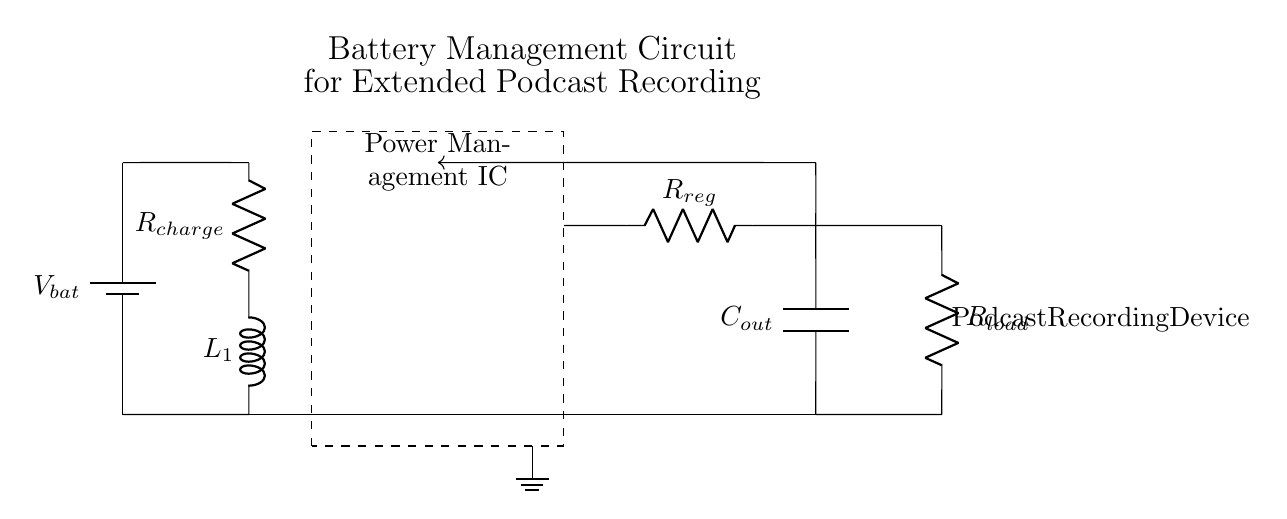What is the component responsible for regulating the output voltage? The component responsible for regulating the output voltage is the voltage regulator, indicated as R sub reg in the circuit.
Answer: R sub reg What does the circuit use to store energy for powering the podcast recording device? The circuit uses an output capacitor, shown as C sub out, to store energy. Energy is stored in capacitors by holding an electric charge.
Answer: C sub out What is the purpose of the Power Management IC block? The Power Management IC block is designed to manage the power supply and distribution within the circuit, ensuring the components receive the correct voltage levels for optimal performance.
Answer: Manage power supply What is the role of the inductor in this circuit? The inductor, labeled as L sub 1, is used in the charging circuit to store energy in a magnetic field and help smooth out fluctuations in the current, enhancing stability during operation.
Answer: Smooth current How does the feedback loop function in this circuit? The feedback loop provides a way to adjust the operation of the power management IC based on the output voltage, allowing for improved regulation of the circuit's performance and maintaining the desired voltage level for the load.
Answer: Adjusts output voltage What is the main load in this battery management circuit? The main load in this battery management circuit is the podcast recording device, which is indicated in the diagram next to the resistor marked as R sub load.
Answer: Podcast recording device What type of connection is used to link the battery to the charging circuit? A short connection is used to link the battery to the charging circuit, as indicated by the short lines in the circuit diagram showing direct connections.
Answer: Short connection 